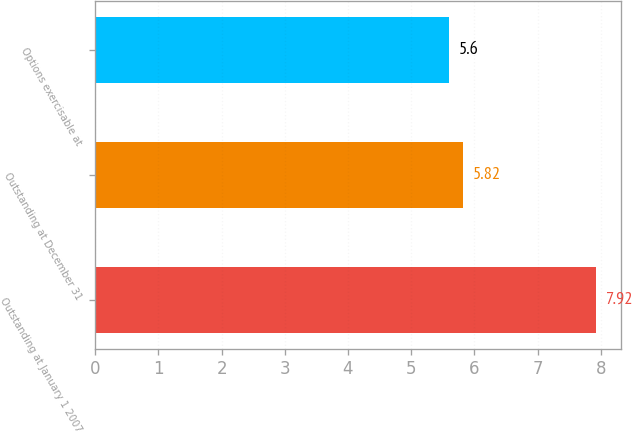Convert chart to OTSL. <chart><loc_0><loc_0><loc_500><loc_500><bar_chart><fcel>Outstanding at January 1 2007<fcel>Outstanding at December 31<fcel>Options exercisable at<nl><fcel>7.92<fcel>5.82<fcel>5.6<nl></chart> 